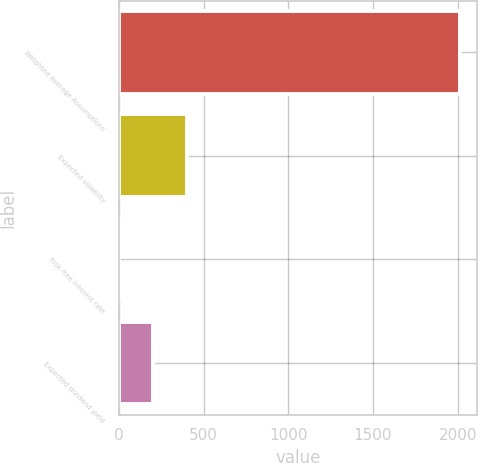Convert chart. <chart><loc_0><loc_0><loc_500><loc_500><bar_chart><fcel>Weighted Average Assumptions<fcel>Expected volatility<fcel>Risk-free interest rate<fcel>Expected dividend yield<nl><fcel>2016<fcel>404.26<fcel>1.32<fcel>202.79<nl></chart> 